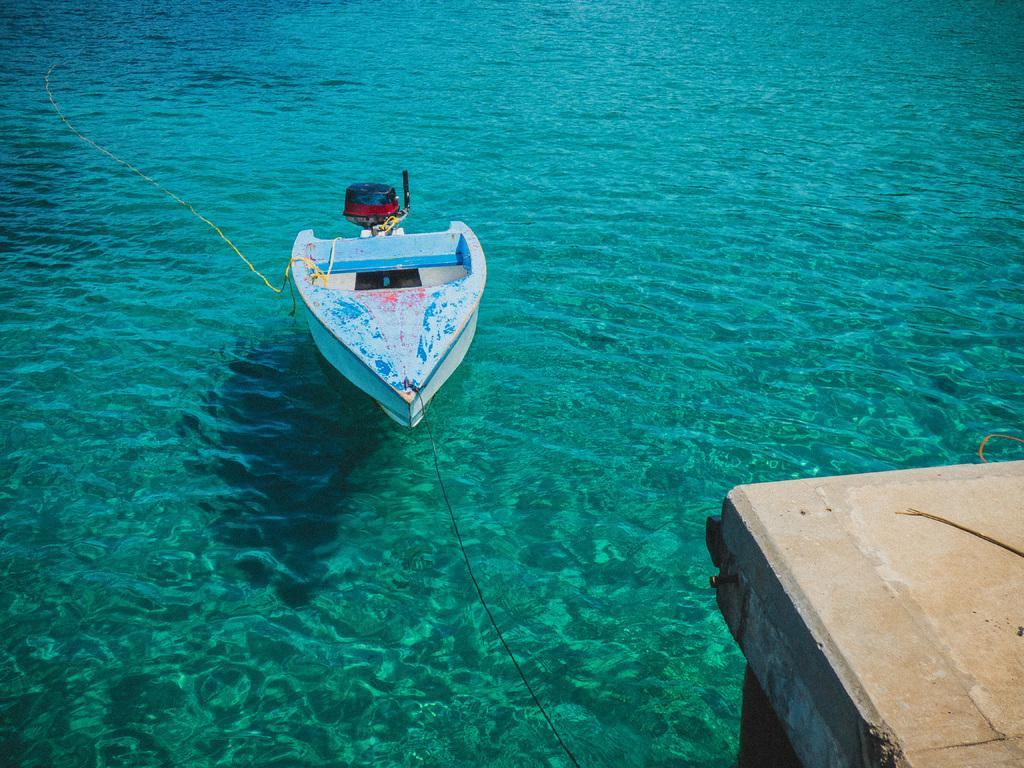Could you give a brief overview of what you see in this image? In the image there is a boat sailing on the water and there is a bridge in the right side and the water is in deep blue color. 